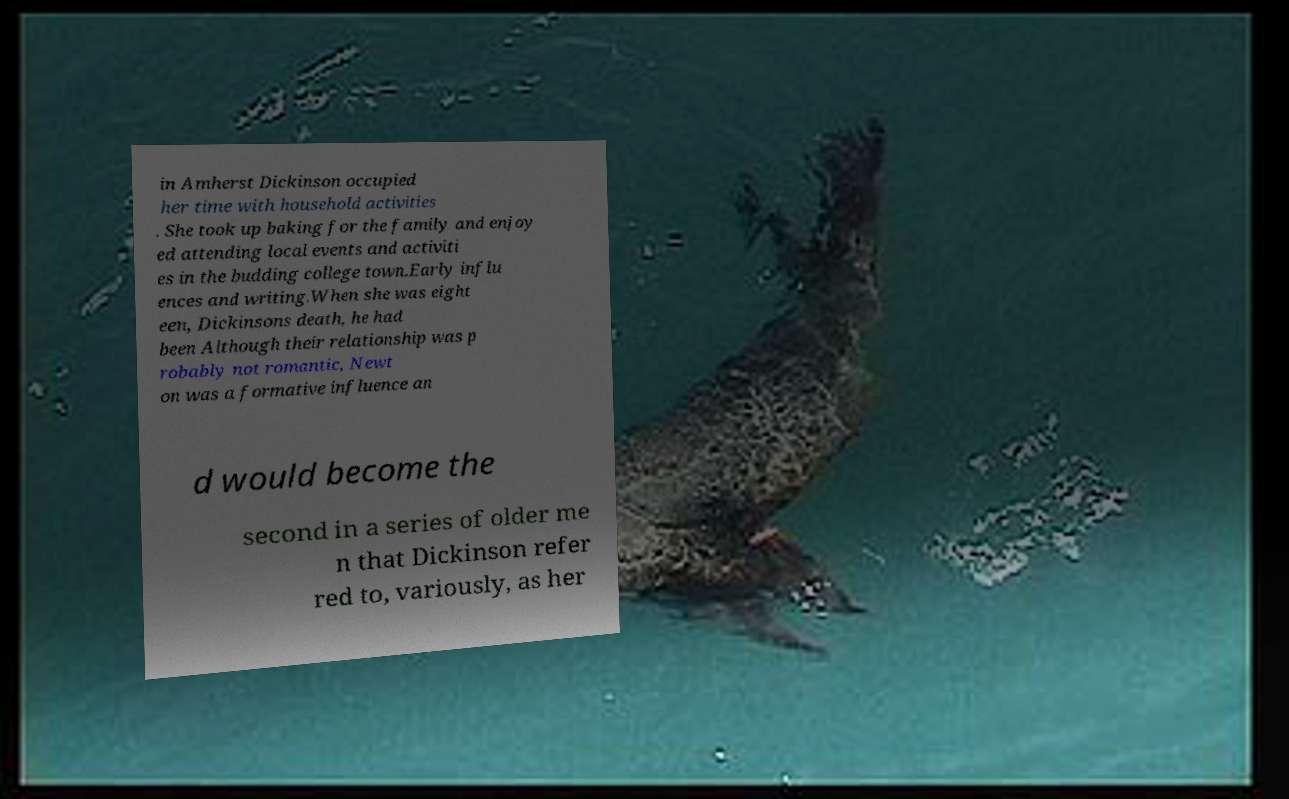Can you accurately transcribe the text from the provided image for me? in Amherst Dickinson occupied her time with household activities . She took up baking for the family and enjoy ed attending local events and activiti es in the budding college town.Early influ ences and writing.When she was eight een, Dickinsons death, he had been Although their relationship was p robably not romantic, Newt on was a formative influence an d would become the second in a series of older me n that Dickinson refer red to, variously, as her 